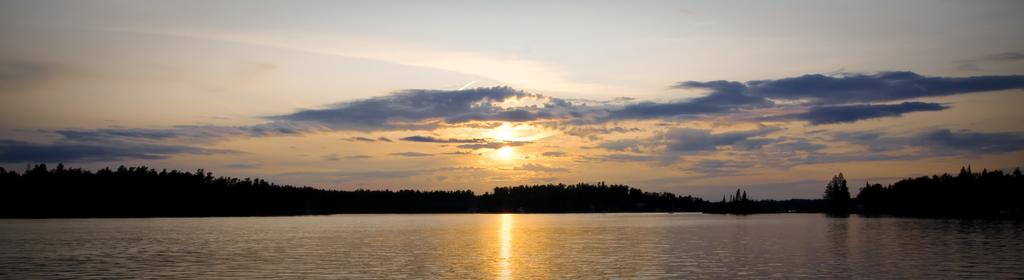What is present in the front of the image? There is water in the front of the image. What can be seen in the background of the image? There are trees and a cloudy sky in the background. Is there any indication of sunlight in the image? Yes, sunlight is visible in the background. What type of crown is placed on the marble table in the image? There is no crown or marble table present in the image. What kind of bread can be seen in the image? There is no bread present in the image. 